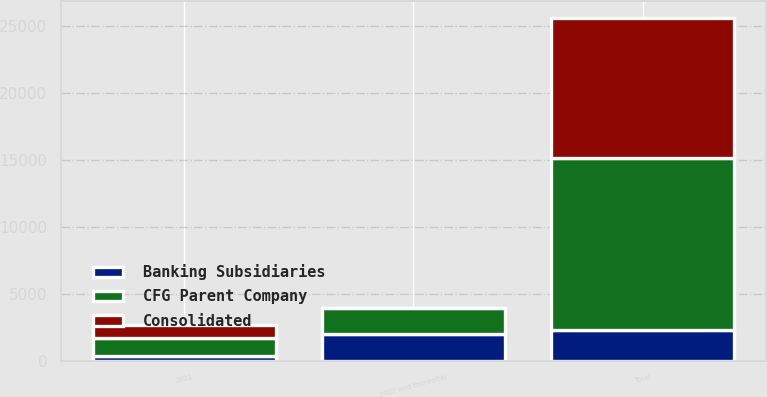Convert chart to OTSL. <chart><loc_0><loc_0><loc_500><loc_500><stacked_bar_chart><ecel><fcel>2021<fcel>2022 and thereafter<fcel>Total<nl><fcel>Banking Subsidiaries<fcel>348<fcel>1970<fcel>2318<nl><fcel>Consolidated<fcel>970<fcel>11<fcel>10472<nl><fcel>CFG Parent Company<fcel>1318<fcel>1981<fcel>12790<nl></chart> 